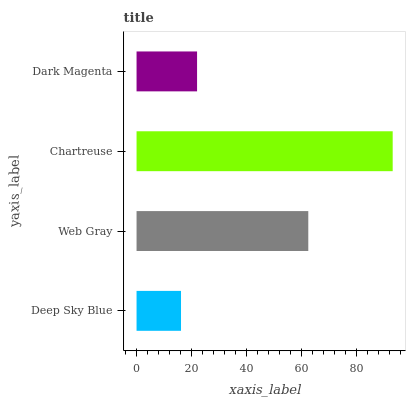Is Deep Sky Blue the minimum?
Answer yes or no. Yes. Is Chartreuse the maximum?
Answer yes or no. Yes. Is Web Gray the minimum?
Answer yes or no. No. Is Web Gray the maximum?
Answer yes or no. No. Is Web Gray greater than Deep Sky Blue?
Answer yes or no. Yes. Is Deep Sky Blue less than Web Gray?
Answer yes or no. Yes. Is Deep Sky Blue greater than Web Gray?
Answer yes or no. No. Is Web Gray less than Deep Sky Blue?
Answer yes or no. No. Is Web Gray the high median?
Answer yes or no. Yes. Is Dark Magenta the low median?
Answer yes or no. Yes. Is Dark Magenta the high median?
Answer yes or no. No. Is Chartreuse the low median?
Answer yes or no. No. 